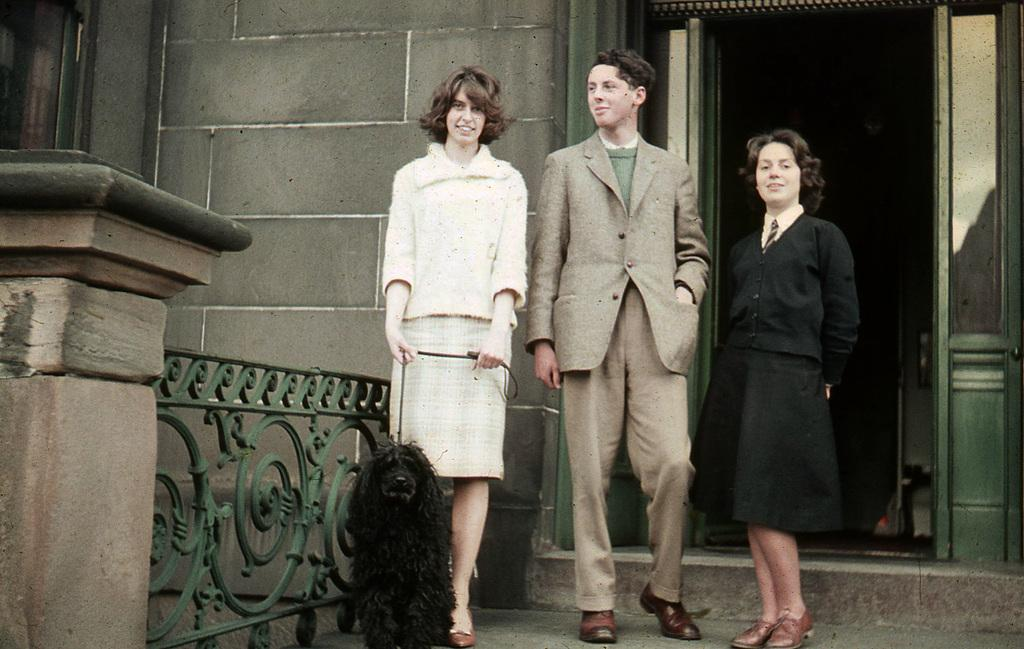How many people are present in the image? There are three persons standing in the image. What is one person holding in the image? One person is holding a dog. What can be seen in the background of the image? There is a wall and a door in the background of the image. What type of surface is visible under the people's feet? The image shows a floor. What type of fork can be seen hanging from the wall in the image? There is no fork present in the image; only a wall and a door are visible in the background. How many additional persons are present in the image, beyond the fifth person? There is no fifth person in the image, as there are only three persons present. 